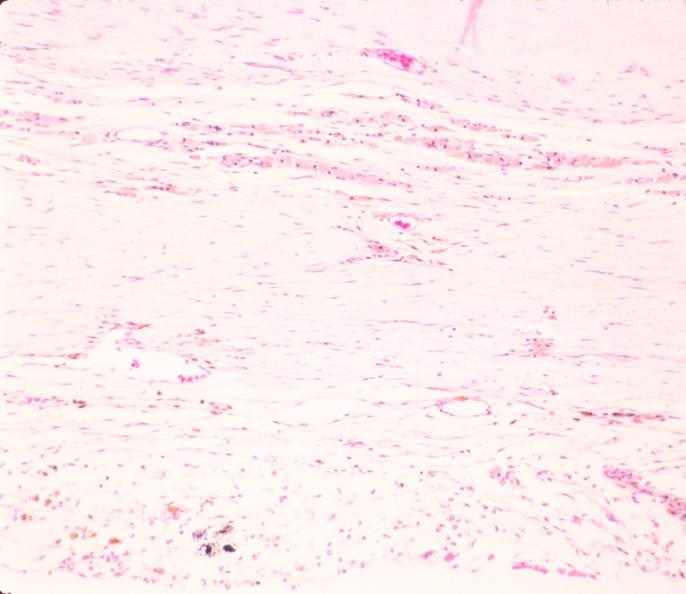why does this image show brain, infarct?
Answer the question using a single word or phrase. Due to ruptured saccular aneurysm and thrombosis of right middle cerebral artery 